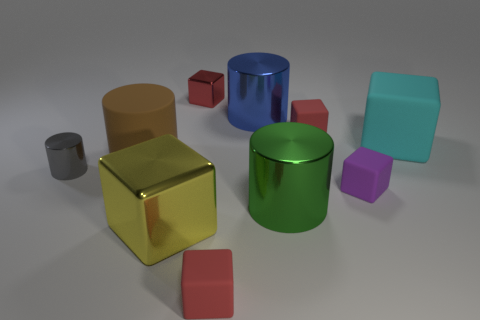The big block that is to the right of the tiny rubber block that is behind the tiny gray shiny thing is made of what material?
Keep it short and to the point. Rubber. Do the blue object and the red metal thing have the same size?
Offer a very short reply. No. How many large things are brown rubber objects or gray cubes?
Offer a very short reply. 1. What number of small metallic cubes are in front of the tiny purple object?
Give a very brief answer. 0. Is the number of cubes that are in front of the yellow metal block greater than the number of gray cylinders?
Provide a succinct answer. No. What is the shape of the big cyan thing that is made of the same material as the purple thing?
Ensure brevity in your answer.  Cube. What is the color of the metallic cylinder left of the small red block in front of the cyan rubber block?
Offer a terse response. Gray. Does the tiny purple thing have the same shape as the large blue thing?
Ensure brevity in your answer.  No. There is a large green thing that is the same shape as the brown rubber thing; what is it made of?
Your response must be concise. Metal. Is there a large yellow block that is to the left of the large shiny cylinder that is behind the small metal thing that is in front of the large blue thing?
Provide a succinct answer. Yes. 